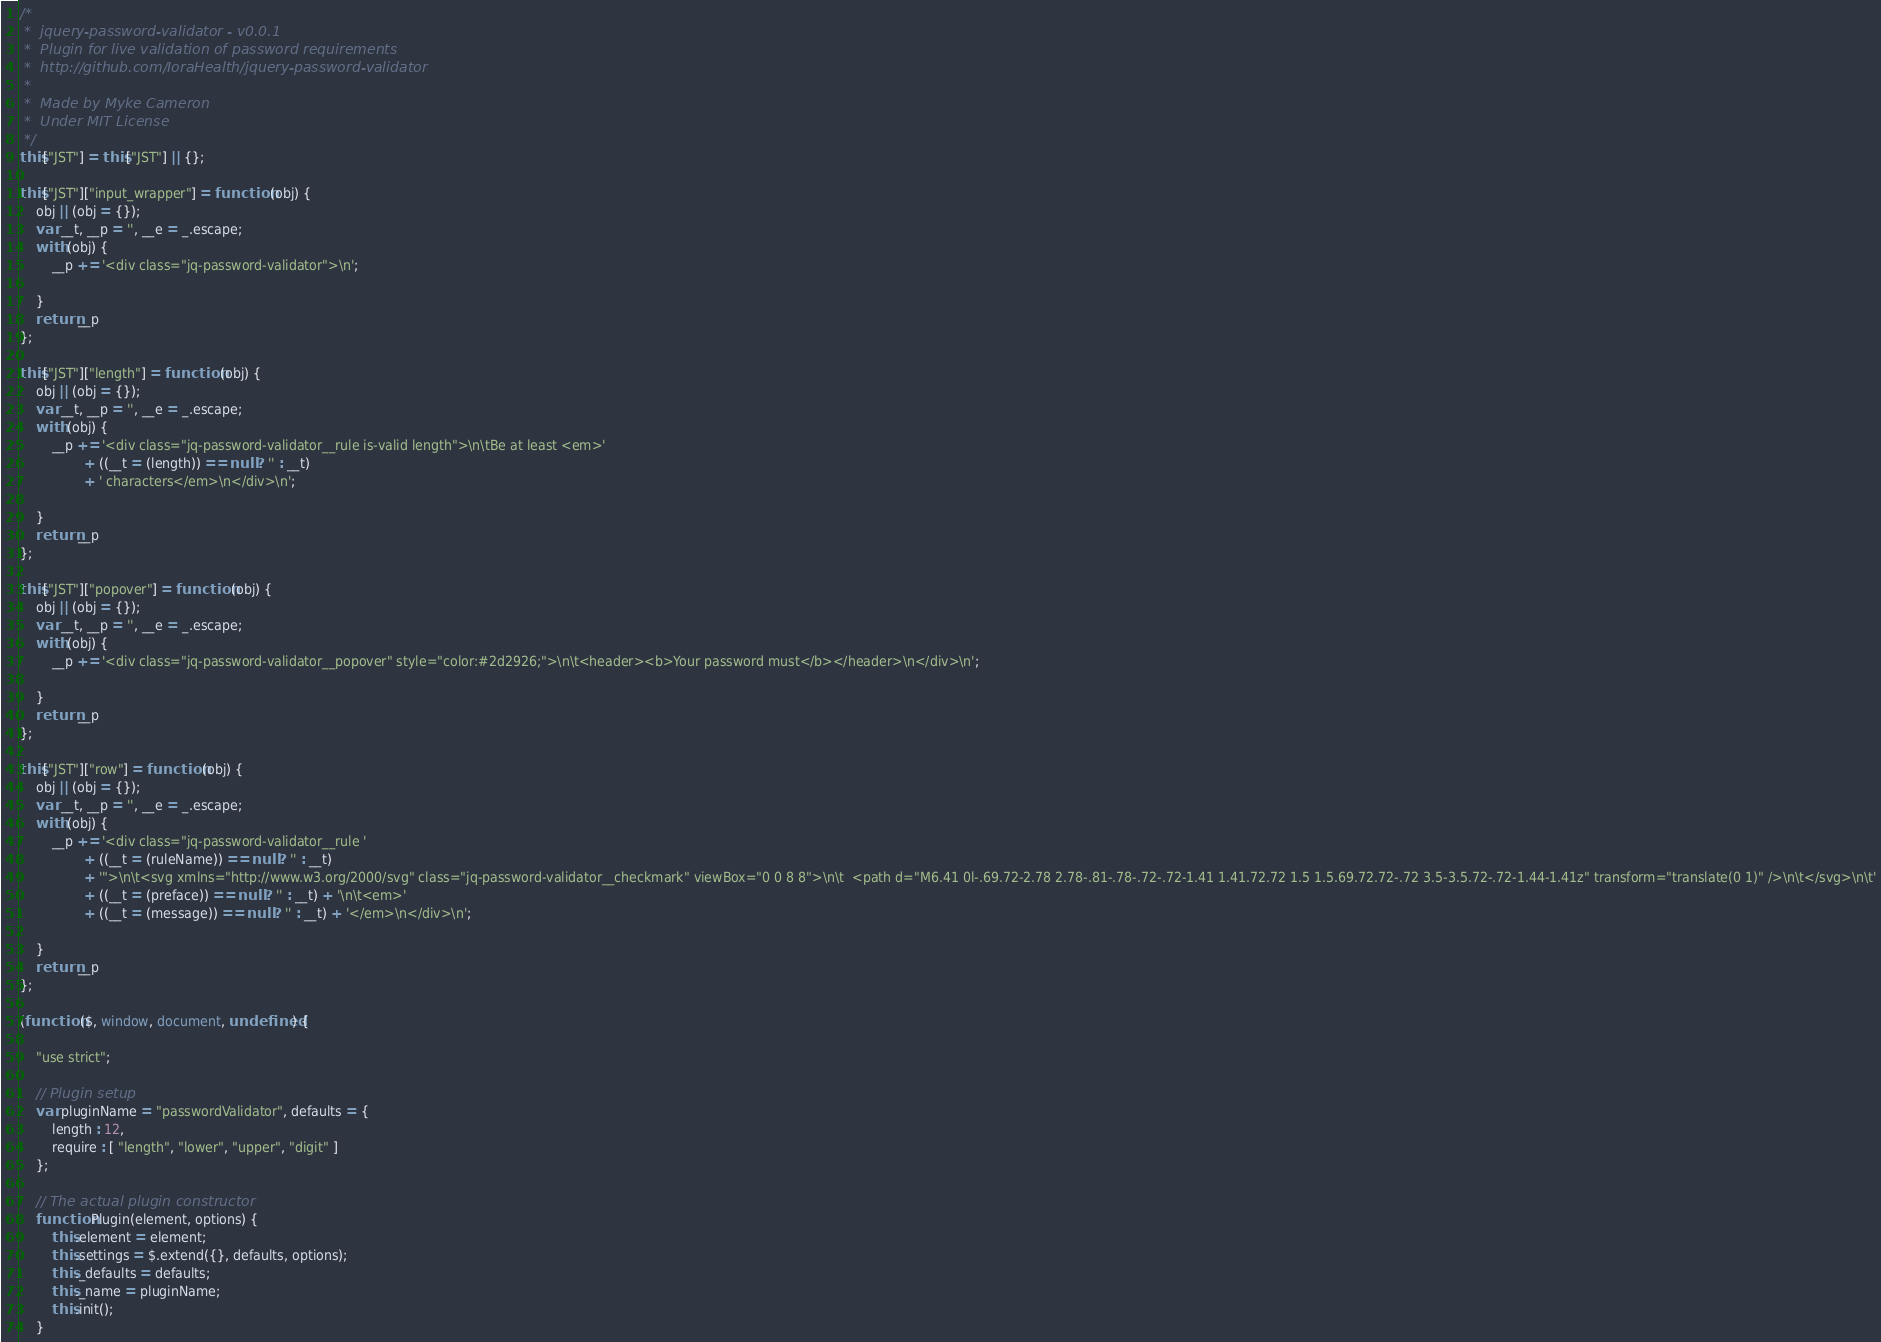<code> <loc_0><loc_0><loc_500><loc_500><_JavaScript_>/*
 *  jquery-password-validator - v0.0.1
 *  Plugin for live validation of password requirements
 *  http://github.com/IoraHealth/jquery-password-validator
 *
 *  Made by Myke Cameron
 *  Under MIT License
 */
this["JST"] = this["JST"] || {};

this["JST"]["input_wrapper"] = function (obj) {
    obj || (obj = {});
    var __t, __p = '', __e = _.escape;
    with (obj) {
        __p += '<div class="jq-password-validator">\n';

    }
    return __p
};

this["JST"]["length"] = function (obj) {
    obj || (obj = {});
    var __t, __p = '', __e = _.escape;
    with (obj) {
        __p += '<div class="jq-password-validator__rule is-valid length">\n\tBe at least <em>'
                + ((__t = (length)) == null ? '' : __t)
                + ' characters</em>\n</div>\n';

    }
    return __p
};

this["JST"]["popover"] = function (obj) {
    obj || (obj = {});
    var __t, __p = '', __e = _.escape;
    with (obj) {
        __p += '<div class="jq-password-validator__popover" style="color:#2d2926;">\n\t<header><b>Your password must</b></header>\n</div>\n';

    }
    return __p
};

this["JST"]["row"] = function (obj) {
    obj || (obj = {});
    var __t, __p = '', __e = _.escape;
    with (obj) {
        __p += '<div class="jq-password-validator__rule '
                + ((__t = (ruleName)) == null ? '' : __t)
                + '">\n\t<svg xmlns="http://www.w3.org/2000/svg" class="jq-password-validator__checkmark" viewBox="0 0 8 8">\n\t  <path d="M6.41 0l-.69.72-2.78 2.78-.81-.78-.72-.72-1.41 1.41.72.72 1.5 1.5.69.72.72-.72 3.5-3.5.72-.72-1.44-1.41z" transform="translate(0 1)" />\n\t</svg>\n\t'
                + ((__t = (preface)) == null ? '' : __t) + '\n\t<em>'
                + ((__t = (message)) == null ? '' : __t) + '</em>\n</div>\n';

    }
    return __p
};

(function ($, window, document, undefined) {

    "use strict";

    // Plugin setup
    var pluginName = "passwordValidator", defaults = {
        length : 12,
        require : [ "length", "lower", "upper", "digit" ]
    };

    // The actual plugin constructor
    function Plugin(element, options) {
        this.element = element;
        this.settings = $.extend({}, defaults, options);
        this._defaults = defaults;
        this._name = pluginName;
        this.init();
    }
</code> 